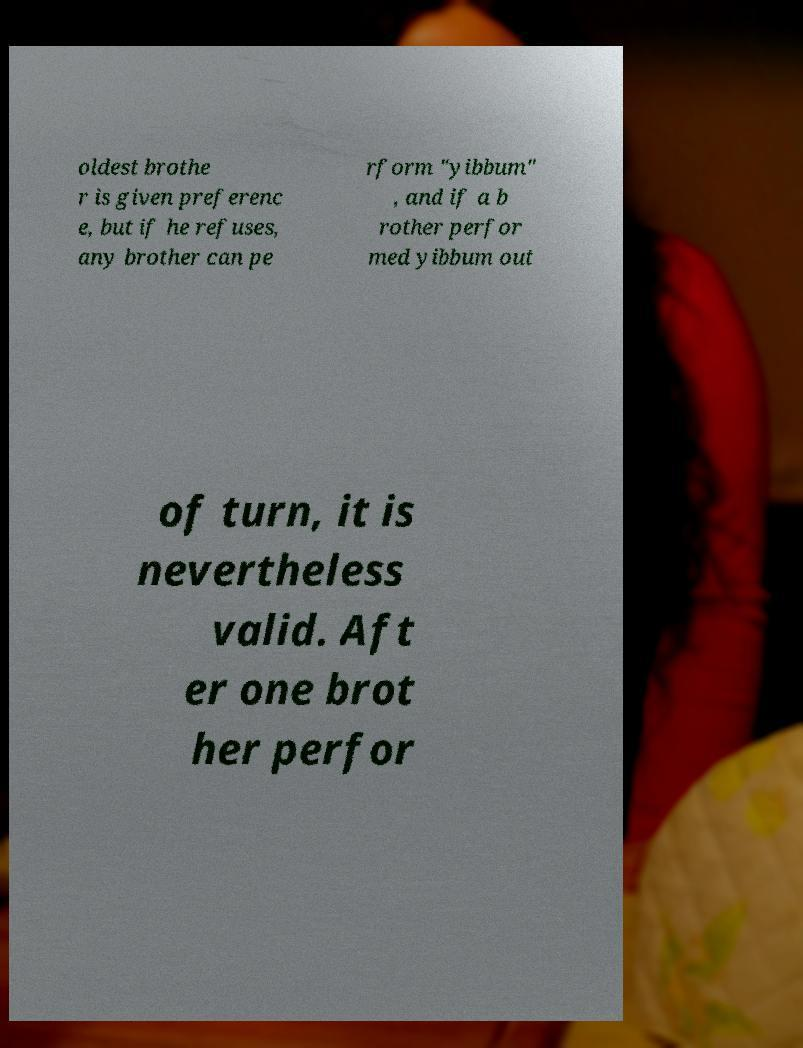Could you extract and type out the text from this image? oldest brothe r is given preferenc e, but if he refuses, any brother can pe rform "yibbum" , and if a b rother perfor med yibbum out of turn, it is nevertheless valid. Aft er one brot her perfor 